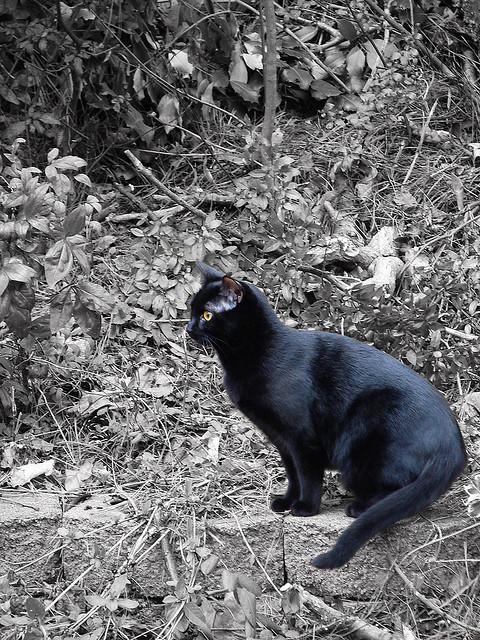Is this photo in color?
Short answer required. Yes. What is the cat sitting on?
Answer briefly. Brick. What color is the cat?
Give a very brief answer. Black. Is this cat outside?
Be succinct. Yes. 